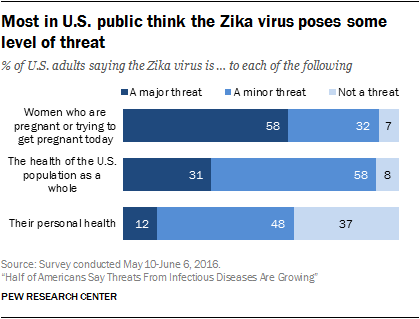Highlight a few significant elements in this photo. The value of the leftmost middle bar is 31. The median of the navy blue bar is not greater than the largest value of the "Not a threat" bar. 